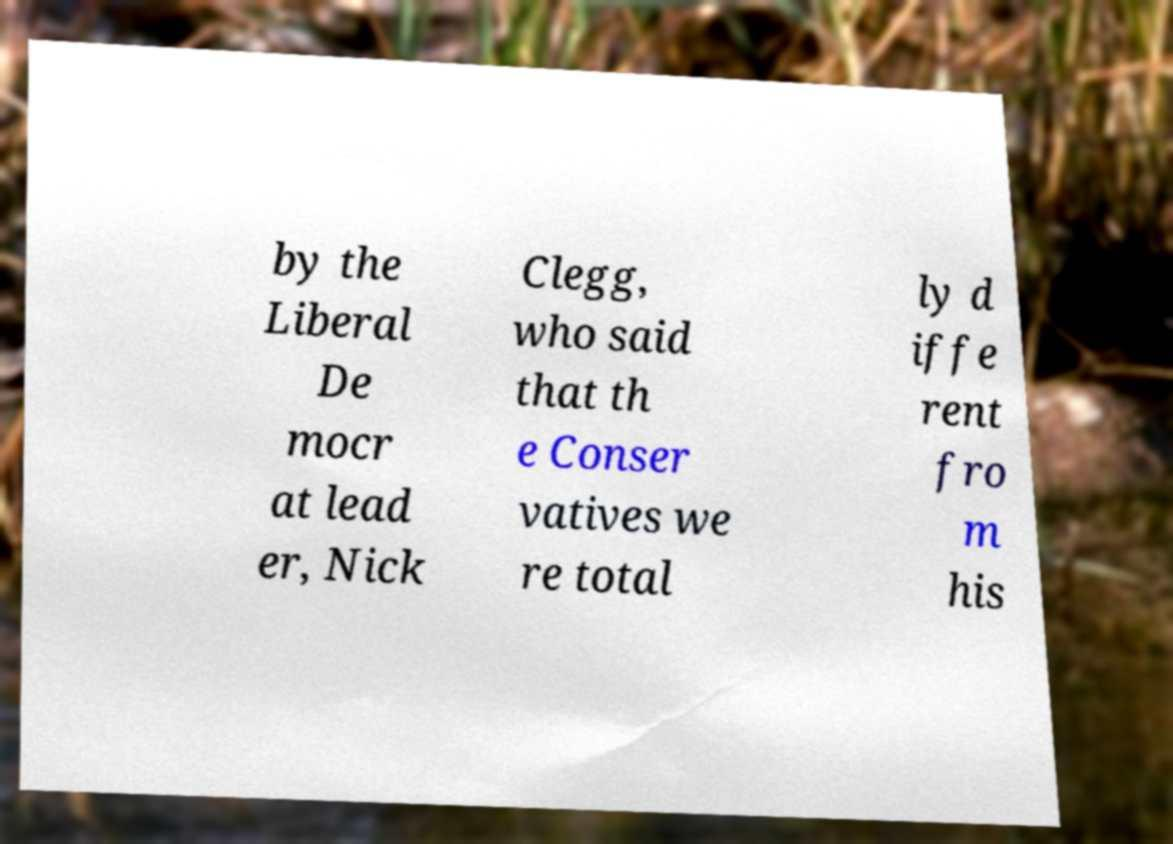Could you assist in decoding the text presented in this image and type it out clearly? by the Liberal De mocr at lead er, Nick Clegg, who said that th e Conser vatives we re total ly d iffe rent fro m his 